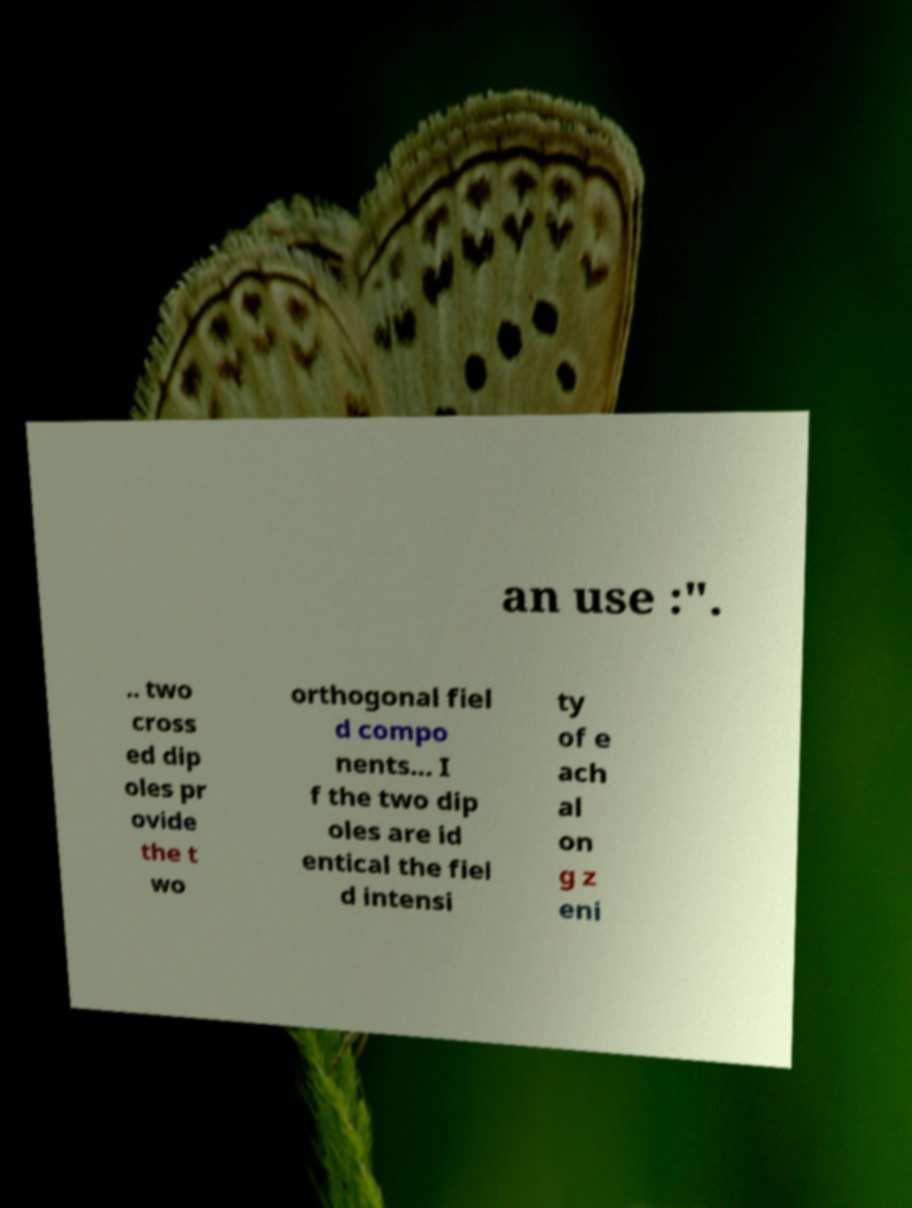I need the written content from this picture converted into text. Can you do that? an use :". .. two cross ed dip oles pr ovide the t wo orthogonal fiel d compo nents... I f the two dip oles are id entical the fiel d intensi ty of e ach al on g z eni 